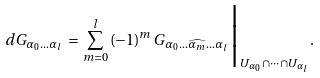<formula> <loc_0><loc_0><loc_500><loc_500>d G _ { \alpha _ { 0 } \dots \alpha _ { l } } \, = \, \sum _ { m = 0 } ^ { l } \, ( - 1 ) ^ { m } \, G _ { \alpha _ { 0 } \dots \widehat { \alpha _ { m } } \dots \alpha _ { l } } \Big | _ { U _ { \alpha _ { 0 } } \cap \dots \cap U _ { \alpha _ { l } } } .</formula> 